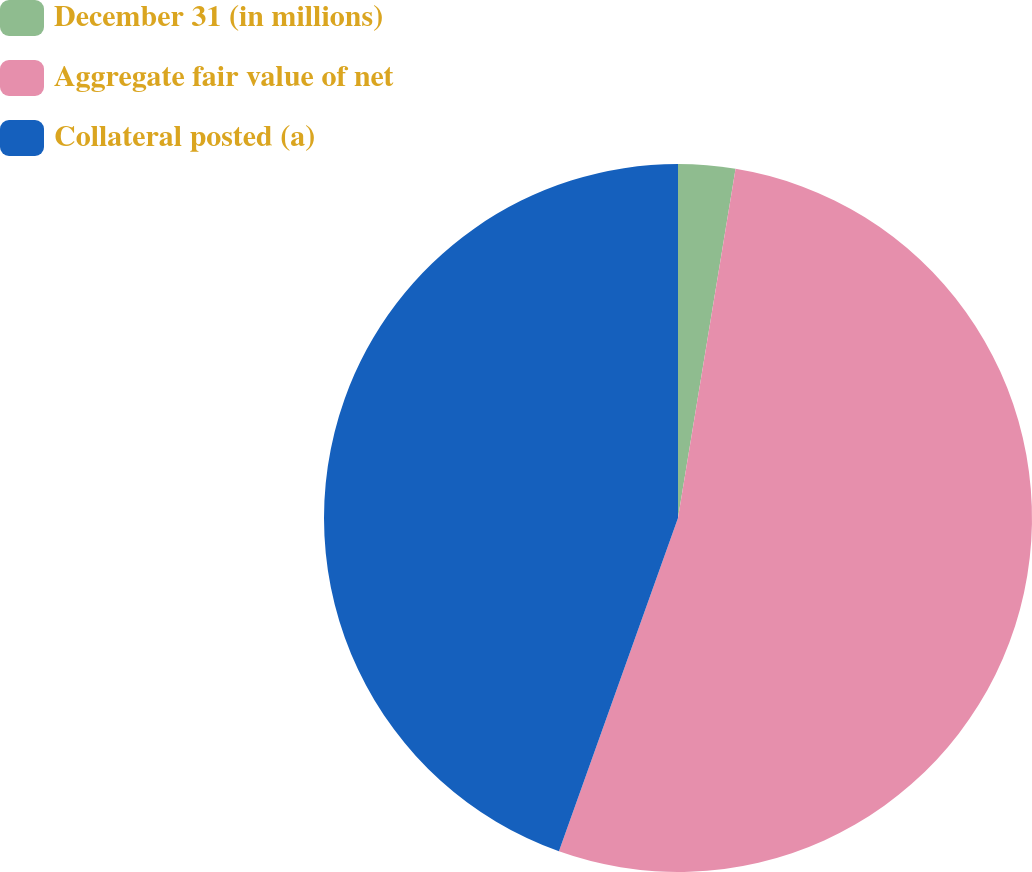Convert chart. <chart><loc_0><loc_0><loc_500><loc_500><pie_chart><fcel>December 31 (in millions)<fcel>Aggregate fair value of net<fcel>Collateral posted (a)<nl><fcel>2.6%<fcel>52.86%<fcel>44.54%<nl></chart> 